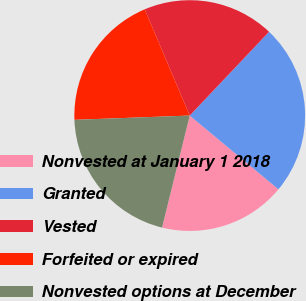<chart> <loc_0><loc_0><loc_500><loc_500><pie_chart><fcel>Nonvested at January 1 2018<fcel>Granted<fcel>Vested<fcel>Forfeited or expired<fcel>Nonvested options at December<nl><fcel>17.82%<fcel>23.97%<fcel>18.44%<fcel>19.21%<fcel>20.55%<nl></chart> 